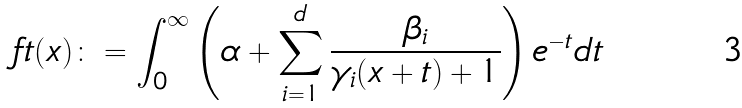Convert formula to latex. <formula><loc_0><loc_0><loc_500><loc_500>\ f t ( x ) \colon = \int _ { 0 } ^ { \infty } \left ( \alpha + \sum _ { i = 1 } ^ { d } \frac { \beta _ { i } } { \gamma _ { i } ( x + t ) + 1 } \right ) e ^ { - t } d t</formula> 